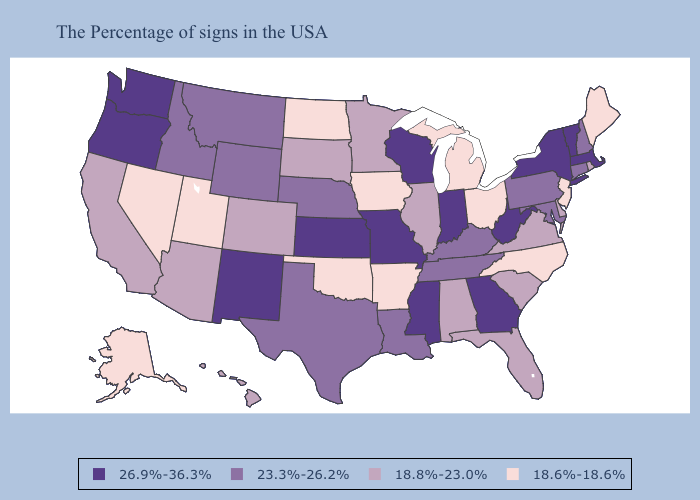Does Nebraska have a lower value than Indiana?
Concise answer only. Yes. What is the highest value in the USA?
Quick response, please. 26.9%-36.3%. Name the states that have a value in the range 18.6%-18.6%?
Answer briefly. Maine, New Jersey, North Carolina, Ohio, Michigan, Arkansas, Iowa, Oklahoma, North Dakota, Utah, Nevada, Alaska. Does Florida have the highest value in the South?
Write a very short answer. No. Which states have the highest value in the USA?
Concise answer only. Massachusetts, Vermont, New York, West Virginia, Georgia, Indiana, Wisconsin, Mississippi, Missouri, Kansas, New Mexico, Washington, Oregon. What is the lowest value in states that border Utah?
Concise answer only. 18.6%-18.6%. What is the value of Oregon?
Short answer required. 26.9%-36.3%. Which states have the lowest value in the Northeast?
Quick response, please. Maine, New Jersey. Does New York have the highest value in the USA?
Concise answer only. Yes. Does the map have missing data?
Write a very short answer. No. Does the map have missing data?
Answer briefly. No. Name the states that have a value in the range 26.9%-36.3%?
Be succinct. Massachusetts, Vermont, New York, West Virginia, Georgia, Indiana, Wisconsin, Mississippi, Missouri, Kansas, New Mexico, Washington, Oregon. What is the highest value in the USA?
Answer briefly. 26.9%-36.3%. Does Oklahoma have the lowest value in the South?
Answer briefly. Yes. What is the lowest value in the USA?
Write a very short answer. 18.6%-18.6%. 